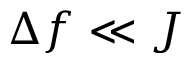<formula> <loc_0><loc_0><loc_500><loc_500>\Delta f \ll J</formula> 